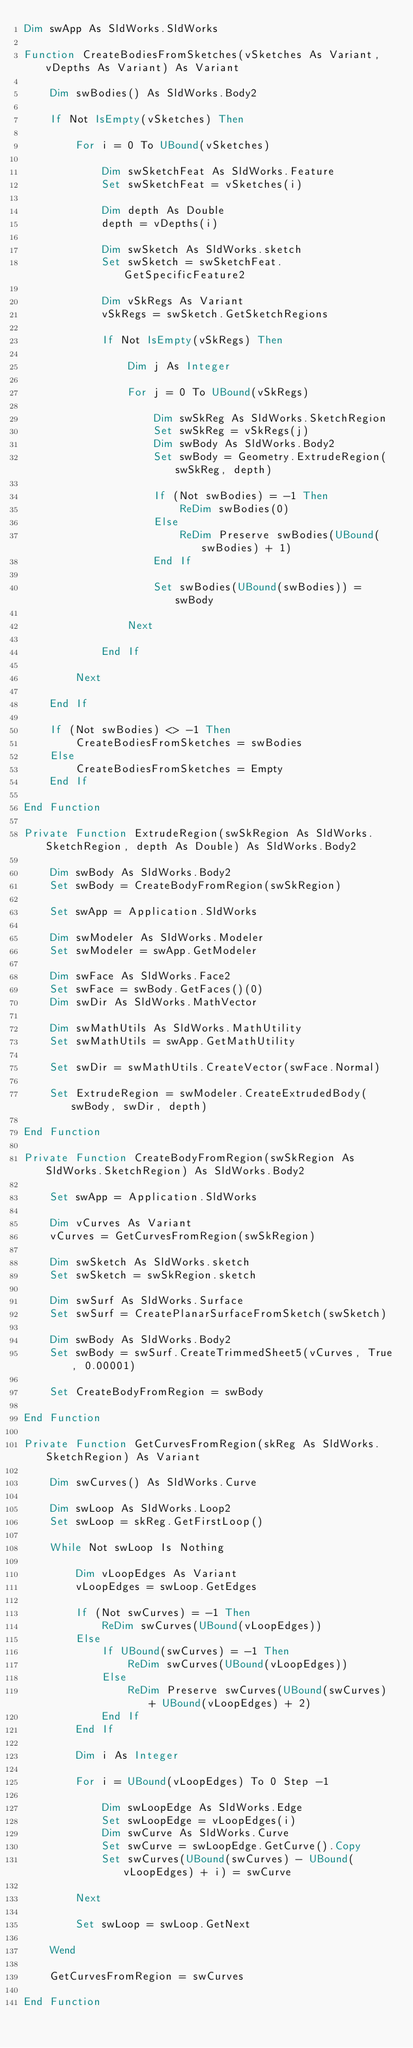<code> <loc_0><loc_0><loc_500><loc_500><_VisualBasic_>Dim swApp As SldWorks.SldWorks

Function CreateBodiesFromSketches(vSketches As Variant, vDepths As Variant) As Variant
    
    Dim swBodies() As SldWorks.Body2
    
    If Not IsEmpty(vSketches) Then
            
        For i = 0 To UBound(vSketches)
            
            Dim swSketchFeat As SldWorks.Feature
            Set swSketchFeat = vSketches(i)
            
            Dim depth As Double
            depth = vDepths(i)
            
            Dim swSketch As SldWorks.sketch
            Set swSketch = swSketchFeat.GetSpecificFeature2
            
            Dim vSkRegs As Variant
            vSkRegs = swSketch.GetSketchRegions
            
            If Not IsEmpty(vSkRegs) Then
                
                Dim j As Integer
                
                For j = 0 To UBound(vSkRegs)
                
                    Dim swSkReg As SldWorks.SketchRegion
                    Set swSkReg = vSkRegs(j)
                    Dim swBody As SldWorks.Body2
                    Set swBody = Geometry.ExtrudeRegion(swSkReg, depth)
                    
                    If (Not swBodies) = -1 Then
                        ReDim swBodies(0)
                    Else
                        ReDim Preserve swBodies(UBound(swBodies) + 1)
                    End If
                    
                    Set swBodies(UBound(swBodies)) = swBody
                    
                Next
                
            End If
            
        Next
            
    End If
    
    If (Not swBodies) <> -1 Then
        CreateBodiesFromSketches = swBodies
    Else
        CreateBodiesFromSketches = Empty
    End If
    
End Function

Private Function ExtrudeRegion(swSkRegion As SldWorks.SketchRegion, depth As Double) As SldWorks.Body2
    
    Dim swBody As SldWorks.Body2
    Set swBody = CreateBodyFromRegion(swSkRegion)
    
    Set swApp = Application.SldWorks
    
    Dim swModeler As SldWorks.Modeler
    Set swModeler = swApp.GetModeler
    
    Dim swFace As SldWorks.Face2
    Set swFace = swBody.GetFaces()(0)
    Dim swDir As SldWorks.MathVector
    
    Dim swMathUtils As SldWorks.MathUtility
    Set swMathUtils = swApp.GetMathUtility
    
    Set swDir = swMathUtils.CreateVector(swFace.Normal)
    
    Set ExtrudeRegion = swModeler.CreateExtrudedBody(swBody, swDir, depth)
    
End Function

Private Function CreateBodyFromRegion(swSkRegion As SldWorks.SketchRegion) As SldWorks.Body2
            
    Set swApp = Application.SldWorks
    
    Dim vCurves As Variant
    vCurves = GetCurvesFromRegion(swSkRegion)
    
    Dim swSketch As SldWorks.sketch
    Set swSketch = swSkRegion.sketch
    
    Dim swSurf As SldWorks.Surface
    Set swSurf = CreatePlanarSurfaceFromSketch(swSketch)
    
    Dim swBody As SldWorks.Body2
    Set swBody = swSurf.CreateTrimmedSheet5(vCurves, True, 0.00001)
    
    Set CreateBodyFromRegion = swBody
    
End Function

Private Function GetCurvesFromRegion(skReg As SldWorks.SketchRegion) As Variant
    
    Dim swCurves() As SldWorks.Curve
    
    Dim swLoop As SldWorks.Loop2
    Set swLoop = skReg.GetFirstLoop()
    
    While Not swLoop Is Nothing
                
        Dim vLoopEdges As Variant
        vLoopEdges = swLoop.GetEdges
        
        If (Not swCurves) = -1 Then
            ReDim swCurves(UBound(vLoopEdges))
        Else
            If UBound(swCurves) = -1 Then
                ReDim swCurves(UBound(vLoopEdges))
            Else
                ReDim Preserve swCurves(UBound(swCurves) + UBound(vLoopEdges) + 2)
            End If
        End If
        
        Dim i As Integer
        
        For i = UBound(vLoopEdges) To 0 Step -1
            
            Dim swLoopEdge As SldWorks.Edge
            Set swLoopEdge = vLoopEdges(i)
            Dim swCurve As SldWorks.Curve
            Set swCurve = swLoopEdge.GetCurve().Copy
            Set swCurves(UBound(swCurves) - UBound(vLoopEdges) + i) = swCurve
            
        Next
        
        Set swLoop = swLoop.GetNext
        
    Wend
    
    GetCurvesFromRegion = swCurves
    
End Function
</code> 